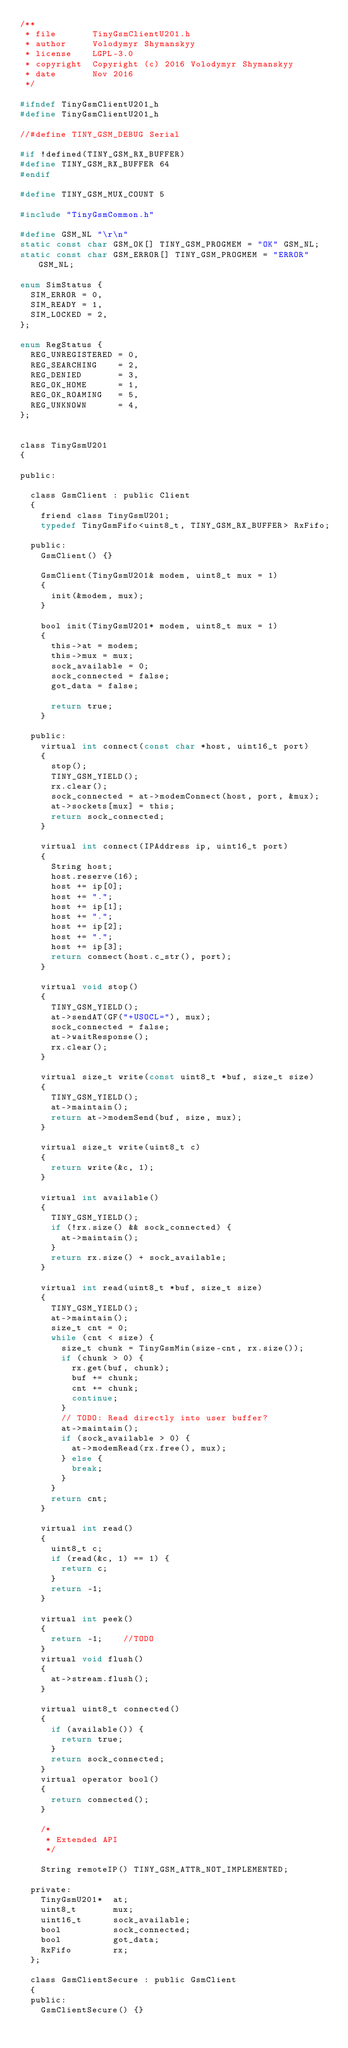<code> <loc_0><loc_0><loc_500><loc_500><_C_>/**
 * file       TinyGsmClientU201.h
 * author     Volodymyr Shymanskyy
 * license    LGPL-3.0
 * copyright  Copyright (c) 2016 Volodymyr Shymanskyy
 * date       Nov 2016
 */

#ifndef TinyGsmClientU201_h
#define TinyGsmClientU201_h

//#define TINY_GSM_DEBUG Serial

#if !defined(TINY_GSM_RX_BUFFER)
#define TINY_GSM_RX_BUFFER 64
#endif

#define TINY_GSM_MUX_COUNT 5

#include "TinyGsmCommon.h"

#define GSM_NL "\r\n"
static const char GSM_OK[] TINY_GSM_PROGMEM = "OK" GSM_NL;
static const char GSM_ERROR[] TINY_GSM_PROGMEM = "ERROR" GSM_NL;

enum SimStatus {
	SIM_ERROR = 0,
	SIM_READY = 1,
	SIM_LOCKED = 2,
};

enum RegStatus {
	REG_UNREGISTERED = 0,
	REG_SEARCHING    = 2,
	REG_DENIED       = 3,
	REG_OK_HOME      = 1,
	REG_OK_ROAMING   = 5,
	REG_UNKNOWN      = 4,
};


class TinyGsmU201
{

public:

	class GsmClient : public Client
	{
		friend class TinyGsmU201;
		typedef TinyGsmFifo<uint8_t, TINY_GSM_RX_BUFFER> RxFifo;

	public:
		GsmClient() {}

		GsmClient(TinyGsmU201& modem, uint8_t mux = 1)
		{
			init(&modem, mux);
		}

		bool init(TinyGsmU201* modem, uint8_t mux = 1)
		{
			this->at = modem;
			this->mux = mux;
			sock_available = 0;
			sock_connected = false;
			got_data = false;

			return true;
		}

	public:
		virtual int connect(const char *host, uint16_t port)
		{
			stop();
			TINY_GSM_YIELD();
			rx.clear();
			sock_connected = at->modemConnect(host, port, &mux);
			at->sockets[mux] = this;
			return sock_connected;
		}

		virtual int connect(IPAddress ip, uint16_t port)
		{
			String host;
			host.reserve(16);
			host += ip[0];
			host += ".";
			host += ip[1];
			host += ".";
			host += ip[2];
			host += ".";
			host += ip[3];
			return connect(host.c_str(), port);
		}

		virtual void stop()
		{
			TINY_GSM_YIELD();
			at->sendAT(GF("+USOCL="), mux);
			sock_connected = false;
			at->waitResponse();
			rx.clear();
		}

		virtual size_t write(const uint8_t *buf, size_t size)
		{
			TINY_GSM_YIELD();
			at->maintain();
			return at->modemSend(buf, size, mux);
		}

		virtual size_t write(uint8_t c)
		{
			return write(&c, 1);
		}

		virtual int available()
		{
			TINY_GSM_YIELD();
			if (!rx.size() && sock_connected) {
				at->maintain();
			}
			return rx.size() + sock_available;
		}

		virtual int read(uint8_t *buf, size_t size)
		{
			TINY_GSM_YIELD();
			at->maintain();
			size_t cnt = 0;
			while (cnt < size) {
				size_t chunk = TinyGsmMin(size-cnt, rx.size());
				if (chunk > 0) {
					rx.get(buf, chunk);
					buf += chunk;
					cnt += chunk;
					continue;
				}
				// TODO: Read directly into user buffer?
				at->maintain();
				if (sock_available > 0) {
					at->modemRead(rx.free(), mux);
				} else {
					break;
				}
			}
			return cnt;
		}

		virtual int read()
		{
			uint8_t c;
			if (read(&c, 1) == 1) {
				return c;
			}
			return -1;
		}

		virtual int peek()
		{
			return -1;    //TODO
		}
		virtual void flush()
		{
			at->stream.flush();
		}

		virtual uint8_t connected()
		{
			if (available()) {
				return true;
			}
			return sock_connected;
		}
		virtual operator bool()
		{
			return connected();
		}

		/*
		 * Extended API
		 */

		String remoteIP() TINY_GSM_ATTR_NOT_IMPLEMENTED;

	private:
		TinyGsmU201*  at;
		uint8_t       mux;
		uint16_t      sock_available;
		bool          sock_connected;
		bool          got_data;
		RxFifo        rx;
	};

	class GsmClientSecure : public GsmClient
	{
	public:
		GsmClientSecure() {}
</code> 